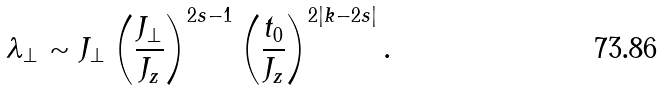Convert formula to latex. <formula><loc_0><loc_0><loc_500><loc_500>\lambda _ { \perp } \sim J _ { \perp } \left ( \frac { J _ { \perp } } { J _ { z } } \right ) ^ { 2 s - 1 } \left ( \frac { t _ { 0 } } { J _ { z } } \right ) ^ { 2 | k - 2 s | } .</formula> 